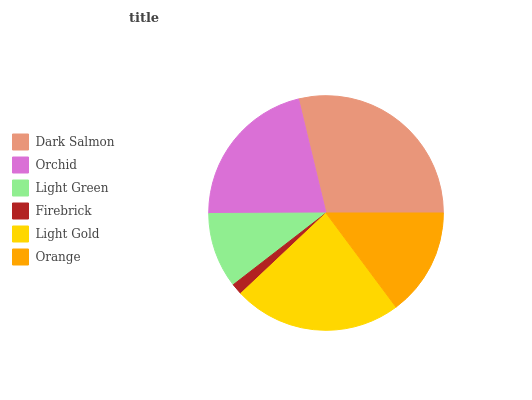Is Firebrick the minimum?
Answer yes or no. Yes. Is Dark Salmon the maximum?
Answer yes or no. Yes. Is Orchid the minimum?
Answer yes or no. No. Is Orchid the maximum?
Answer yes or no. No. Is Dark Salmon greater than Orchid?
Answer yes or no. Yes. Is Orchid less than Dark Salmon?
Answer yes or no. Yes. Is Orchid greater than Dark Salmon?
Answer yes or no. No. Is Dark Salmon less than Orchid?
Answer yes or no. No. Is Orchid the high median?
Answer yes or no. Yes. Is Orange the low median?
Answer yes or no. Yes. Is Orange the high median?
Answer yes or no. No. Is Orchid the low median?
Answer yes or no. No. 